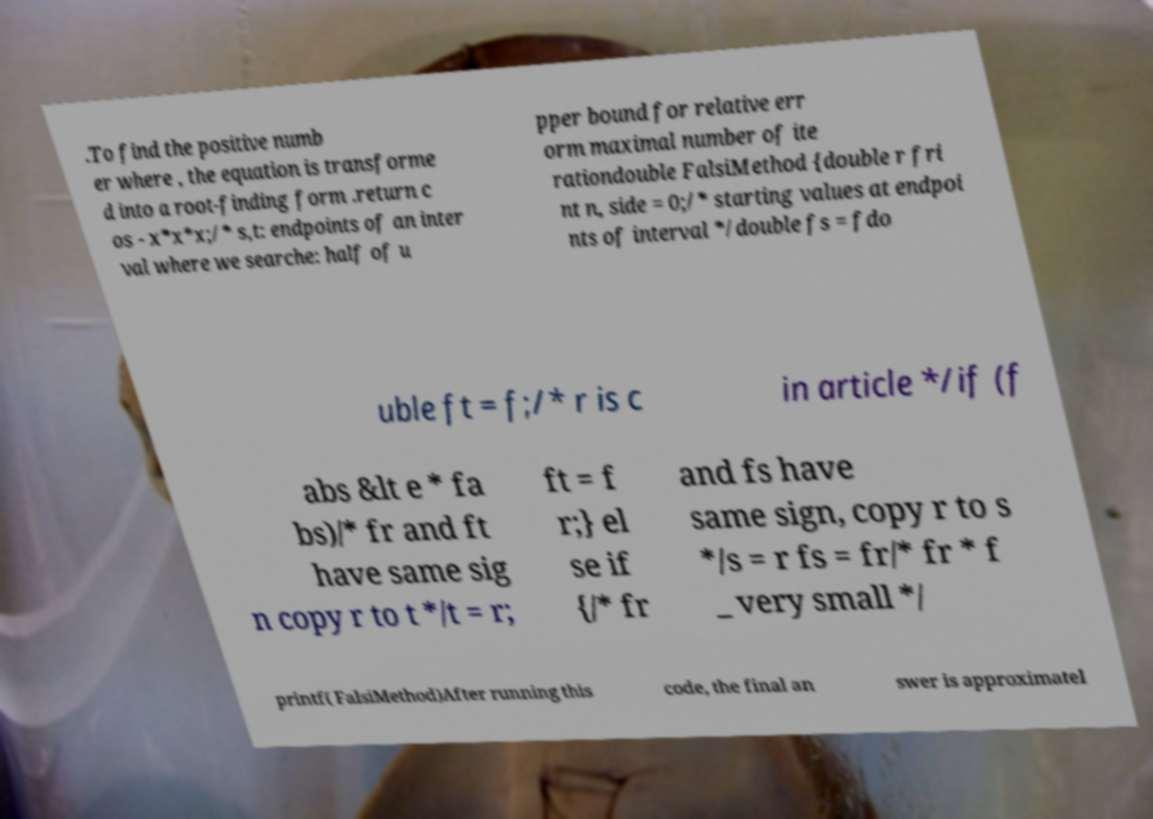Can you read and provide the text displayed in the image?This photo seems to have some interesting text. Can you extract and type it out for me? .To find the positive numb er where , the equation is transforme d into a root-finding form .return c os - x*x*x;/* s,t: endpoints of an inter val where we searche: half of u pper bound for relative err orm maximal number of ite rationdouble FalsiMethod {double r fri nt n, side = 0;/* starting values at endpoi nts of interval */double fs = fdo uble ft = f;/* r is c in article */if (f abs &lt e * fa bs)/* fr and ft have same sig n copy r to t */t = r; ft = f r;} el se if {/* fr and fs have same sign, copy r to s */s = r fs = fr/* fr * f _ very small */ printf( FalsiMethod)After running this code, the final an swer is approximatel 